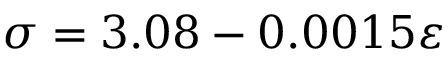Convert formula to latex. <formula><loc_0><loc_0><loc_500><loc_500>\sigma = 3 . 0 8 - 0 . 0 0 1 5 \varepsilon</formula> 